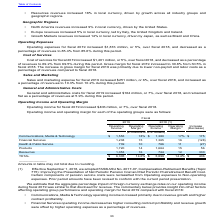According to Accenture Plc's financial document, What is the change in total operating income between 2018 and 2019? According to the financial document, $406 (in millions). The relevant text states: "Operating income for fiscal 2019 increased $406 million, or 7%, over fiscal 2018...." Also, What is the operating margin for health and public service in 2019? According to the financial document, 10 (percentage). The relevant text states: "Health & Public Service 739 10 766 11 (27)..." Also, What is the company's operating income in 2019? According to the financial document, $6,305 (in millions). The relevant text states: "TOTAL $ 6,305 14.6% $ 5,899 14.4% $ 406..." Additionally, What is the company's main source of operating income in 2019? According to the financial document, Products. The relevant text states: "Products 1,720 14 1,664 15 56..." Also, can you calculate: How much did total operating income gain from 2018 to 2019? Based on the calculation: 406/5,899, the result is 6.88 (percentage). This is based on the information: "TOTAL $ 6,305 14.6% $ 5,899 14.4% $ 406 Operating income for fiscal 2019 increased $406 million, or 7%, over fiscal 2018...." The key data points involved are: 406, 5,899. Also, can you calculate: What is the total operating margin from financial services and products in 2019? Based on the calculation: 15% + 14% , the result is 29 (percentage). This is based on the information: "Products 1,720 14 1,664 15 56 Products 1,720 14 1,664 15 56..." The key data points involved are: 14, 15. 